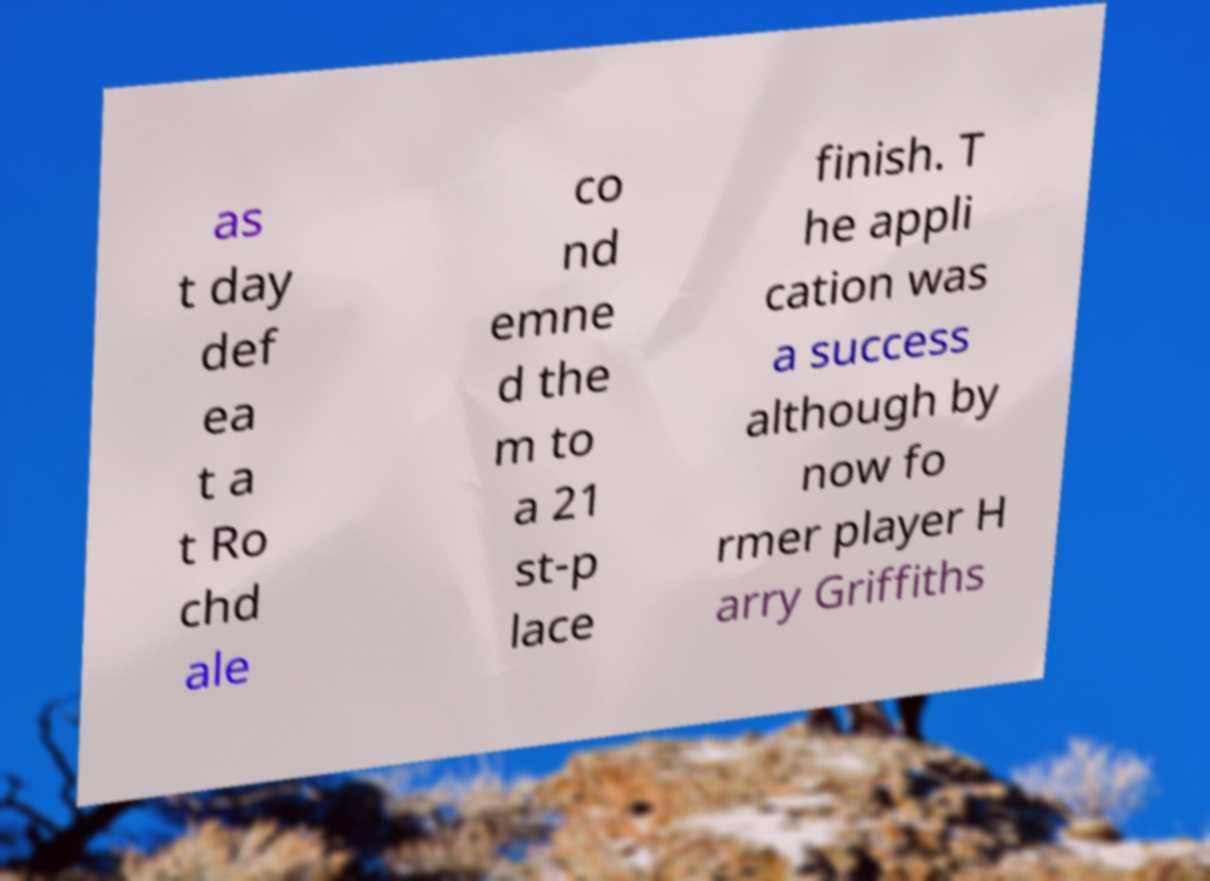Could you assist in decoding the text presented in this image and type it out clearly? as t day def ea t a t Ro chd ale co nd emne d the m to a 21 st-p lace finish. T he appli cation was a success although by now fo rmer player H arry Griffiths 